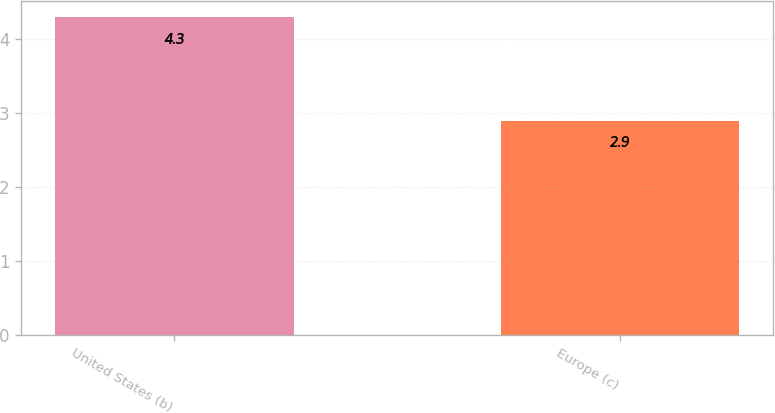<chart> <loc_0><loc_0><loc_500><loc_500><bar_chart><fcel>United States (b)<fcel>Europe (c)<nl><fcel>4.3<fcel>2.9<nl></chart> 